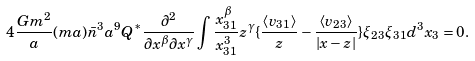Convert formula to latex. <formula><loc_0><loc_0><loc_500><loc_500>4 \frac { G m ^ { 2 } } { a } ( m a ) \bar { n } ^ { 3 } a ^ { 9 } Q ^ { * } \frac { \partial ^ { 2 } } { \partial x ^ { \beta } \partial x ^ { \gamma } } \int \frac { x _ { 3 1 } ^ { \beta } } { x _ { 3 1 } ^ { 3 } } z ^ { \gamma } \{ \frac { \langle v _ { 3 1 } \rangle } { z } - \frac { \langle v _ { 2 3 } \rangle } { | x - z | } \} \xi _ { 2 3 } \xi _ { 3 1 } d ^ { 3 } x _ { 3 } = 0 .</formula> 